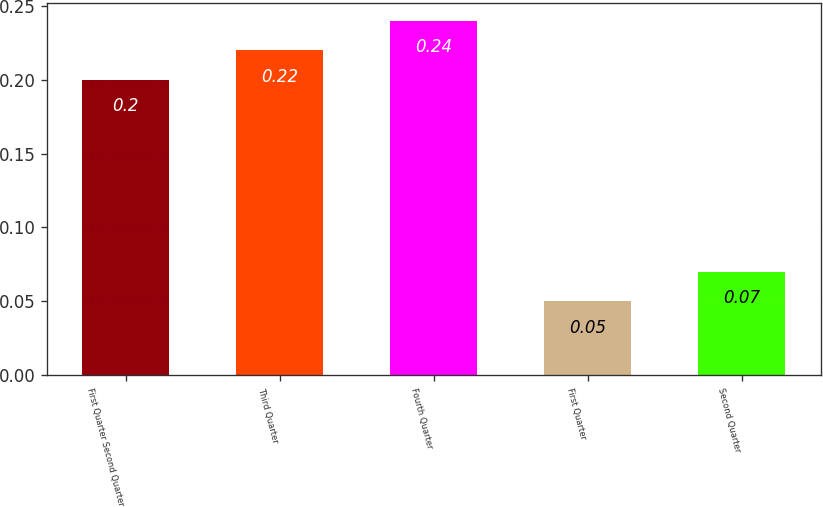Convert chart. <chart><loc_0><loc_0><loc_500><loc_500><bar_chart><fcel>First Quarter Second Quarter<fcel>Third Quarter<fcel>Fourth Quarter<fcel>First Quarter<fcel>Second Quarter<nl><fcel>0.2<fcel>0.22<fcel>0.24<fcel>0.05<fcel>0.07<nl></chart> 